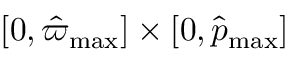<formula> <loc_0><loc_0><loc_500><loc_500>[ 0 , \hat { \varpi } _ { \max } ] \times [ 0 , \hat { p } _ { \max } ]</formula> 